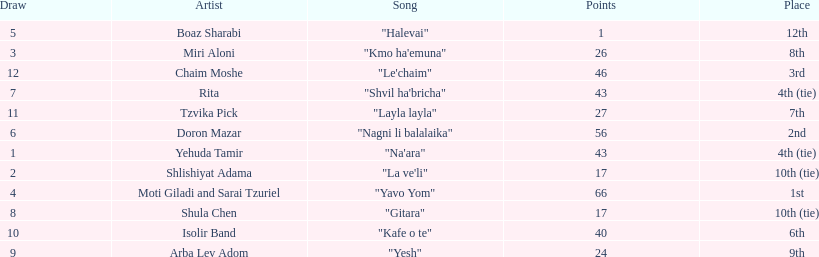What is the name of the first song listed on this chart? "Na'ara". I'm looking to parse the entire table for insights. Could you assist me with that? {'header': ['Draw', 'Artist', 'Song', 'Points', 'Place'], 'rows': [['5', 'Boaz Sharabi', '"Halevai"', '1', '12th'], ['3', 'Miri Aloni', '"Kmo ha\'emuna"', '26', '8th'], ['12', 'Chaim Moshe', '"Le\'chaim"', '46', '3rd'], ['7', 'Rita', '"Shvil ha\'bricha"', '43', '4th (tie)'], ['11', 'Tzvika Pick', '"Layla layla"', '27', '7th'], ['6', 'Doron Mazar', '"Nagni li balalaika"', '56', '2nd'], ['1', 'Yehuda Tamir', '"Na\'ara"', '43', '4th (tie)'], ['2', 'Shlishiyat Adama', '"La ve\'li"', '17', '10th (tie)'], ['4', 'Moti Giladi and Sarai Tzuriel', '"Yavo Yom"', '66', '1st'], ['8', 'Shula Chen', '"Gitara"', '17', '10th (tie)'], ['10', 'Isolir Band', '"Kafe o te"', '40', '6th'], ['9', 'Arba Lev Adom', '"Yesh"', '24', '9th']]} 